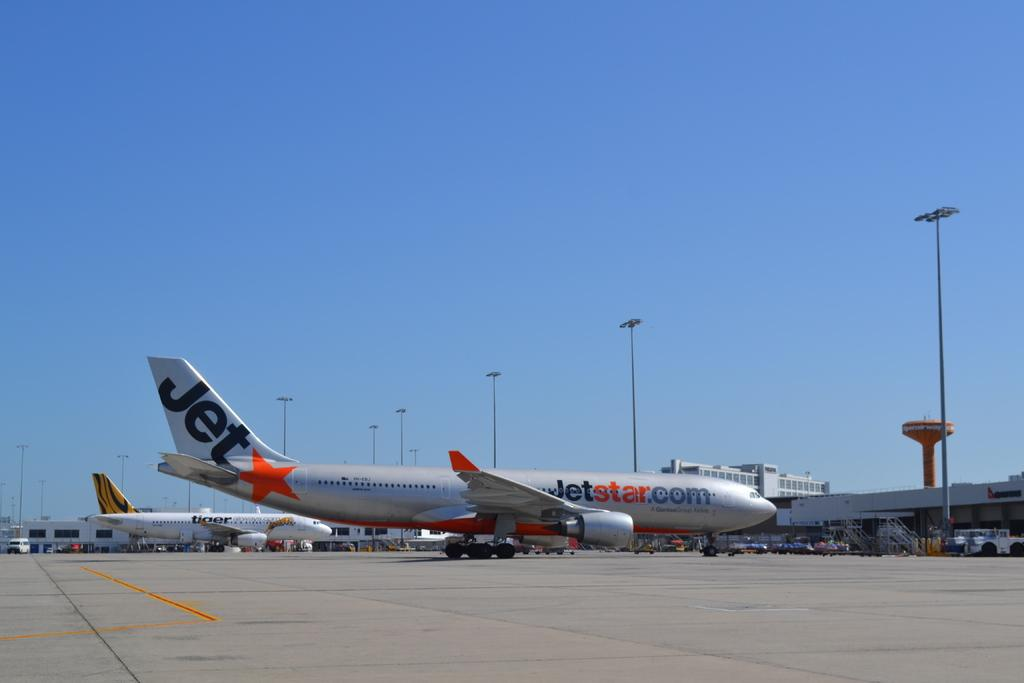<image>
Summarize the visual content of the image. a white plane with the word jet on the back of it 